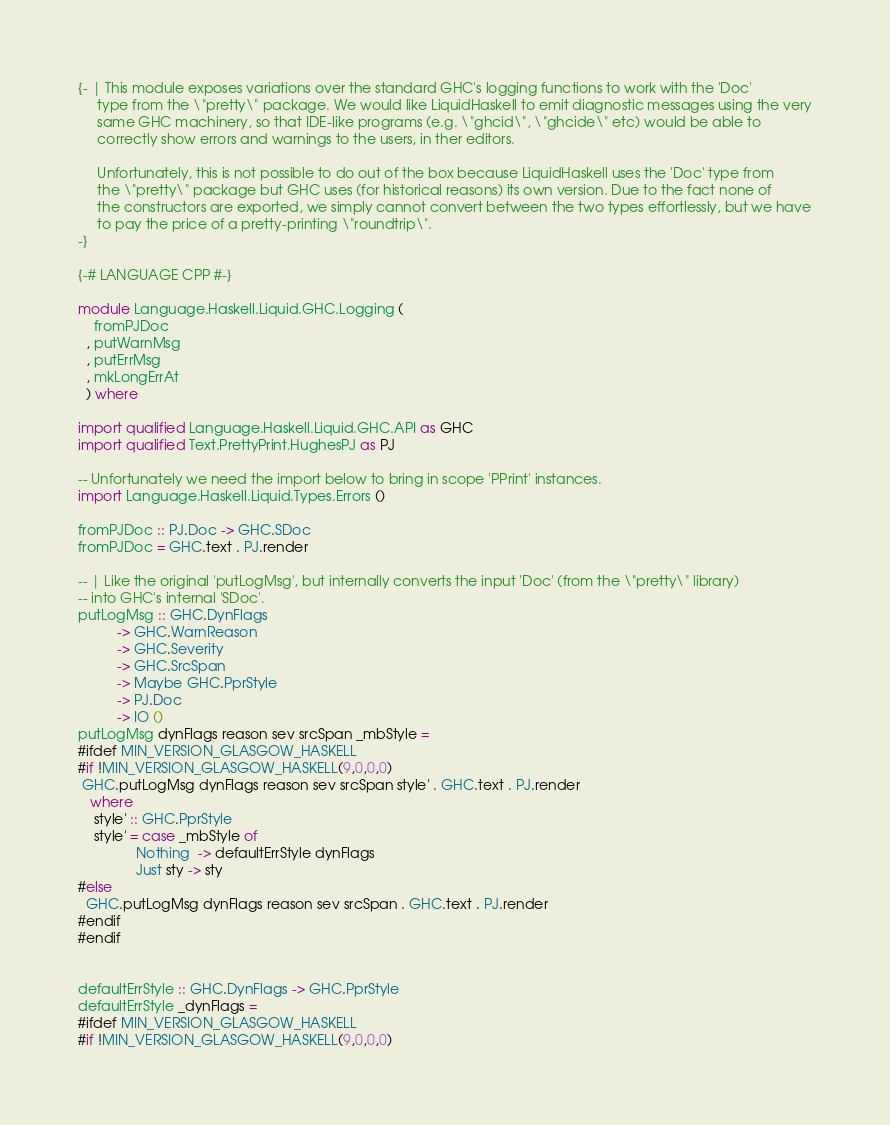Convert code to text. <code><loc_0><loc_0><loc_500><loc_500><_Haskell_>{- | This module exposes variations over the standard GHC's logging functions to work with the 'Doc'
     type from the \"pretty\" package. We would like LiquidHaskell to emit diagnostic messages using the very
     same GHC machinery, so that IDE-like programs (e.g. \"ghcid\", \"ghcide\" etc) would be able to
     correctly show errors and warnings to the users, in ther editors.

     Unfortunately, this is not possible to do out of the box because LiquidHaskell uses the 'Doc' type from
     the \"pretty\" package but GHC uses (for historical reasons) its own version. Due to the fact none of
     the constructors are exported, we simply cannot convert between the two types effortlessly, but we have
     to pay the price of a pretty-printing \"roundtrip\".
-}

{-# LANGUAGE CPP #-}

module Language.Haskell.Liquid.GHC.Logging (
    fromPJDoc
  , putWarnMsg
  , putErrMsg
  , mkLongErrAt
  ) where

import qualified Language.Haskell.Liquid.GHC.API as GHC
import qualified Text.PrettyPrint.HughesPJ as PJ

-- Unfortunately we need the import below to bring in scope 'PPrint' instances.
import Language.Haskell.Liquid.Types.Errors ()

fromPJDoc :: PJ.Doc -> GHC.SDoc
fromPJDoc = GHC.text . PJ.render

-- | Like the original 'putLogMsg', but internally converts the input 'Doc' (from the \"pretty\" library)
-- into GHC's internal 'SDoc'.
putLogMsg :: GHC.DynFlags
          -> GHC.WarnReason
          -> GHC.Severity
          -> GHC.SrcSpan
          -> Maybe GHC.PprStyle
          -> PJ.Doc
          -> IO ()
putLogMsg dynFlags reason sev srcSpan _mbStyle =
#ifdef MIN_VERSION_GLASGOW_HASKELL
#if !MIN_VERSION_GLASGOW_HASKELL(9,0,0,0)
 GHC.putLogMsg dynFlags reason sev srcSpan style' . GHC.text . PJ.render
   where
    style' :: GHC.PprStyle
    style' = case _mbStyle of
               Nothing  -> defaultErrStyle dynFlags
               Just sty -> sty
#else
  GHC.putLogMsg dynFlags reason sev srcSpan . GHC.text . PJ.render
#endif
#endif


defaultErrStyle :: GHC.DynFlags -> GHC.PprStyle
defaultErrStyle _dynFlags =
#ifdef MIN_VERSION_GLASGOW_HASKELL
#if !MIN_VERSION_GLASGOW_HASKELL(9,0,0,0)</code> 